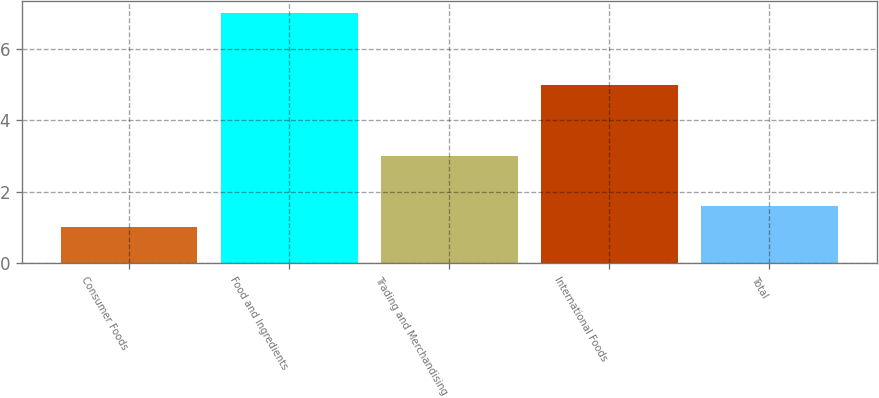<chart> <loc_0><loc_0><loc_500><loc_500><bar_chart><fcel>Consumer Foods<fcel>Food and Ingredients<fcel>Trading and Merchandising<fcel>International Foods<fcel>Total<nl><fcel>1<fcel>7<fcel>3<fcel>5<fcel>1.6<nl></chart> 